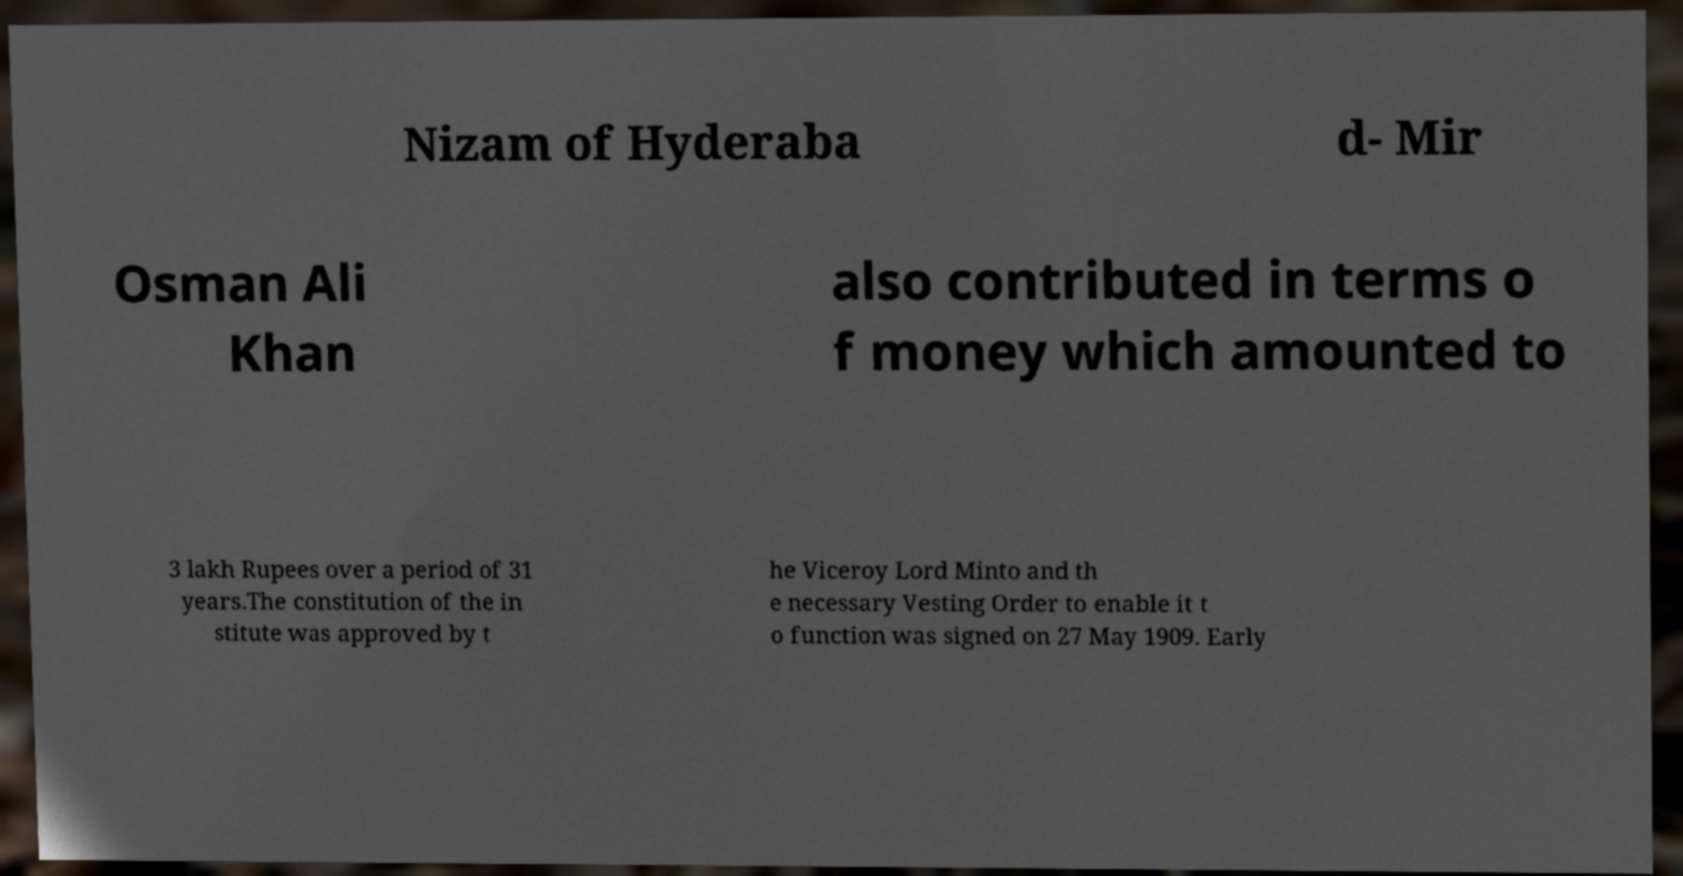Could you extract and type out the text from this image? Nizam of Hyderaba d- Mir Osman Ali Khan also contributed in terms o f money which amounted to 3 lakh Rupees over a period of 31 years.The constitution of the in stitute was approved by t he Viceroy Lord Minto and th e necessary Vesting Order to enable it t o function was signed on 27 May 1909. Early 